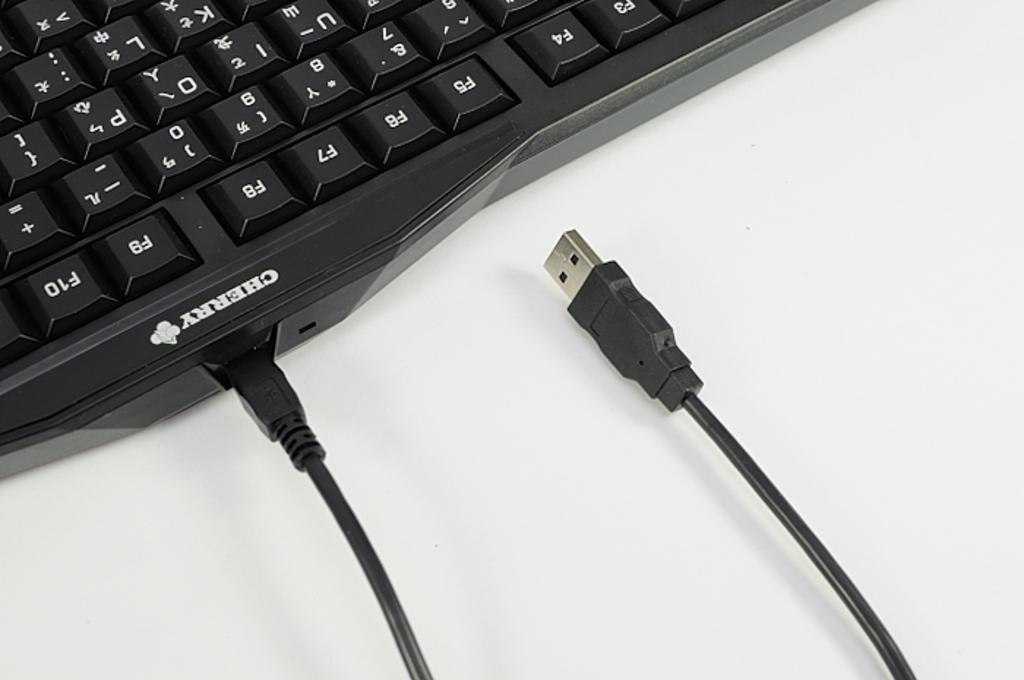<image>
Write a terse but informative summary of the picture. usb cord plugging into a keyboard that says Cherry on it. 